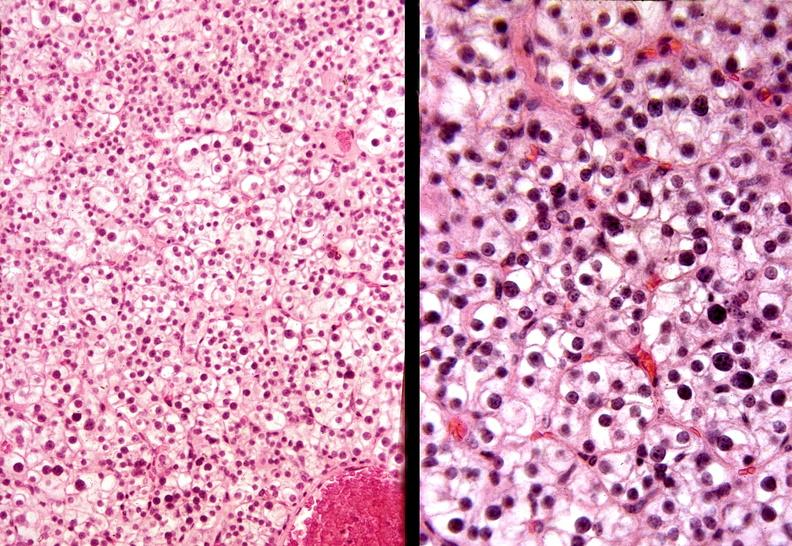what does this image show?
Answer the question using a single word or phrase. Parathyroid 